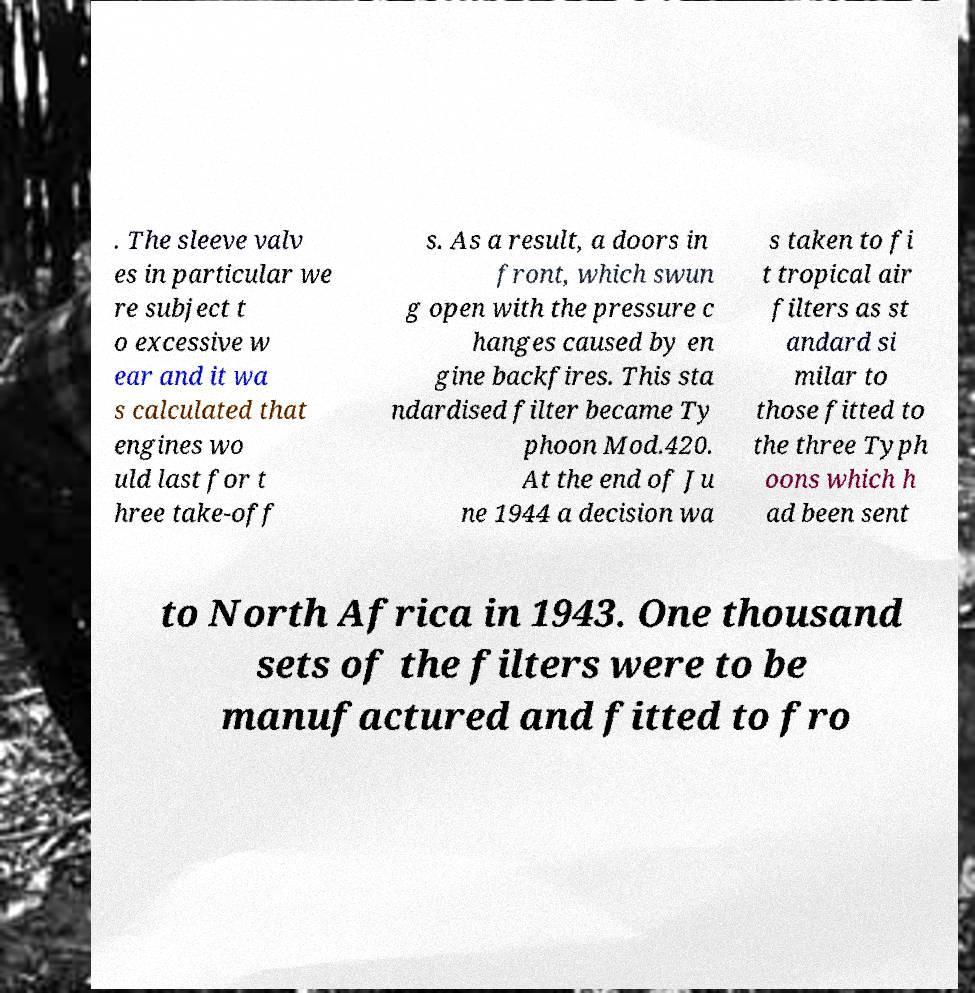Can you accurately transcribe the text from the provided image for me? . The sleeve valv es in particular we re subject t o excessive w ear and it wa s calculated that engines wo uld last for t hree take-off s. As a result, a doors in front, which swun g open with the pressure c hanges caused by en gine backfires. This sta ndardised filter became Ty phoon Mod.420. At the end of Ju ne 1944 a decision wa s taken to fi t tropical air filters as st andard si milar to those fitted to the three Typh oons which h ad been sent to North Africa in 1943. One thousand sets of the filters were to be manufactured and fitted to fro 